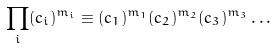<formula> <loc_0><loc_0><loc_500><loc_500>\prod _ { i } ( c _ { i } ) ^ { m _ { i } } \equiv ( c _ { 1 } ) ^ { m _ { 1 } } ( c _ { 2 } ) ^ { m _ { 2 } } ( c _ { 3 } ) ^ { m _ { 3 } } \dots</formula> 